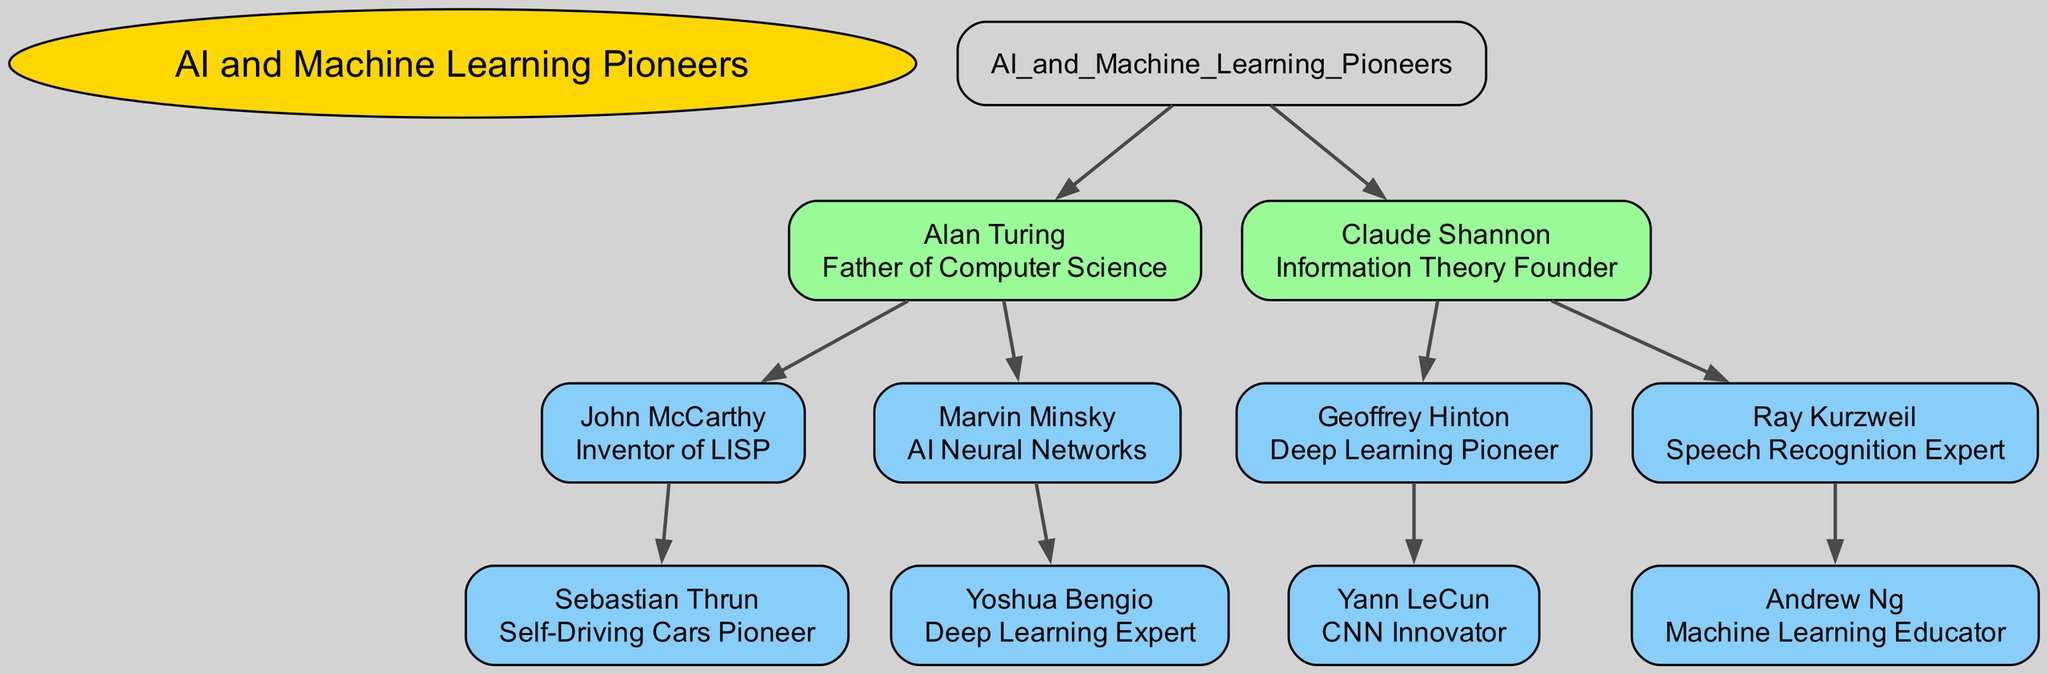What is the title of Alan Turing? Alan Turing is labeled as the "Father of Computer Science" in the diagram, which is directly associated with his node.
Answer: Father of Computer Science How many children does Claude Shannon have in the diagram? By observing the node representing Claude Shannon, we can count two child nodes connected to him: Geoffrey Hinton and Ray Kurzweil.
Answer: 2 Who is the child of John McCarthy? The node for John McCarthy has one child node, which is Sebastian Thrun. This is determined by only having one connection flowing downward from his node.
Answer: Sebastian Thrun What is the relationship between Ray Kurzweil and Andrew Ng? The relationship represented in the diagram shows that Andrew Ng is the child of Ray Kurzweil, indicated by the direct edge linking them.
Answer: Child Which pioneer is directly connected to both neural networks and deep learning? The diagram illustrates that Marvin Minsky, credited with AI Neural Networks, has a descendant, Yoshua Bengio, recognized as a Deep Learning Expert, forming a direct line connection.
Answer: Marvin Minsky Who is recognized as the "CNN Innovator"? Yann LeCun is labeled as the "CNN Innovator," as indicated in his node, which is connected to Geoffrey Hinton, his parent.
Answer: Yann LeCun Which node has the most descendants in this family tree? By tracing the child nodes, we see that Claude Shannon has the greatest number of descendants (four: Geoffrey Hinton, Yann LeCun, Ray Kurzweil, and Andrew Ng) compared to others in the diagram.
Answer: Claude Shannon What is the role of Sebastian Thrun in the AI community? The diagram designates Sebastian Thrun as the "Self-Driving Cars Pioneer," representing his significant contributions in that field.
Answer: Self-Driving Cars Pioneer How many generations are represented in the family tree? In total, there are three generations present: the root (AI and Machine Learning Pioneers), the first generation (Alan Turing and Claude Shannon), and the second generation (the children of Alan Turing and Claude Shannon).
Answer: 3 